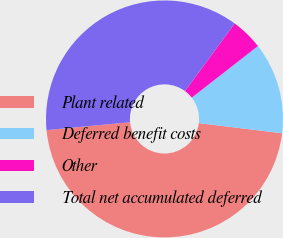<chart> <loc_0><loc_0><loc_500><loc_500><pie_chart><fcel>Plant related<fcel>Deferred benefit costs<fcel>Other<fcel>Total net accumulated deferred<nl><fcel>46.57%<fcel>12.47%<fcel>4.37%<fcel>36.59%<nl></chart> 